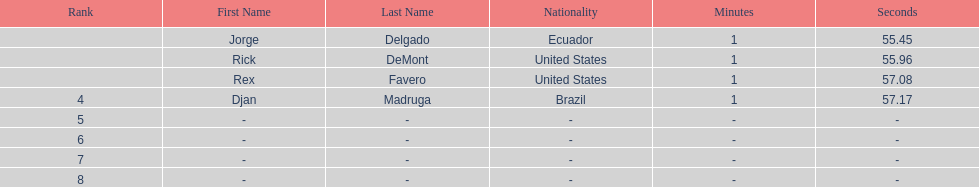What is the time for each name 1:55.45, 1:55.96, 1:57.08, 1:57.17. 